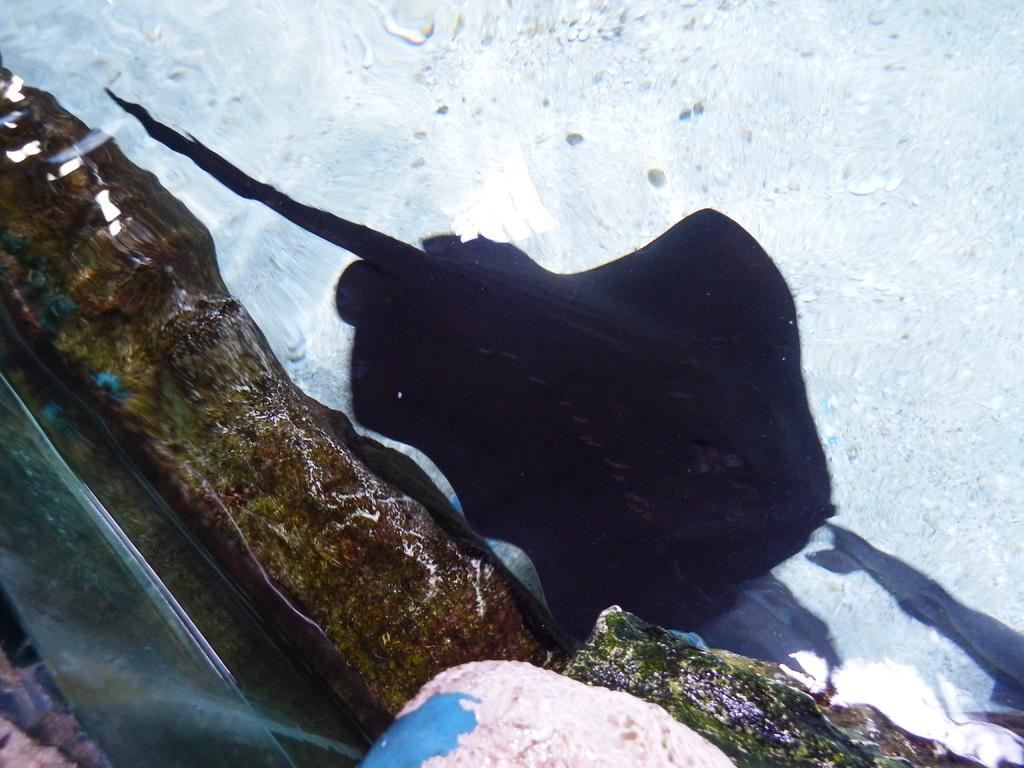Please provide a concise description of this image. In this image we can see a fish and the rock in the water. 